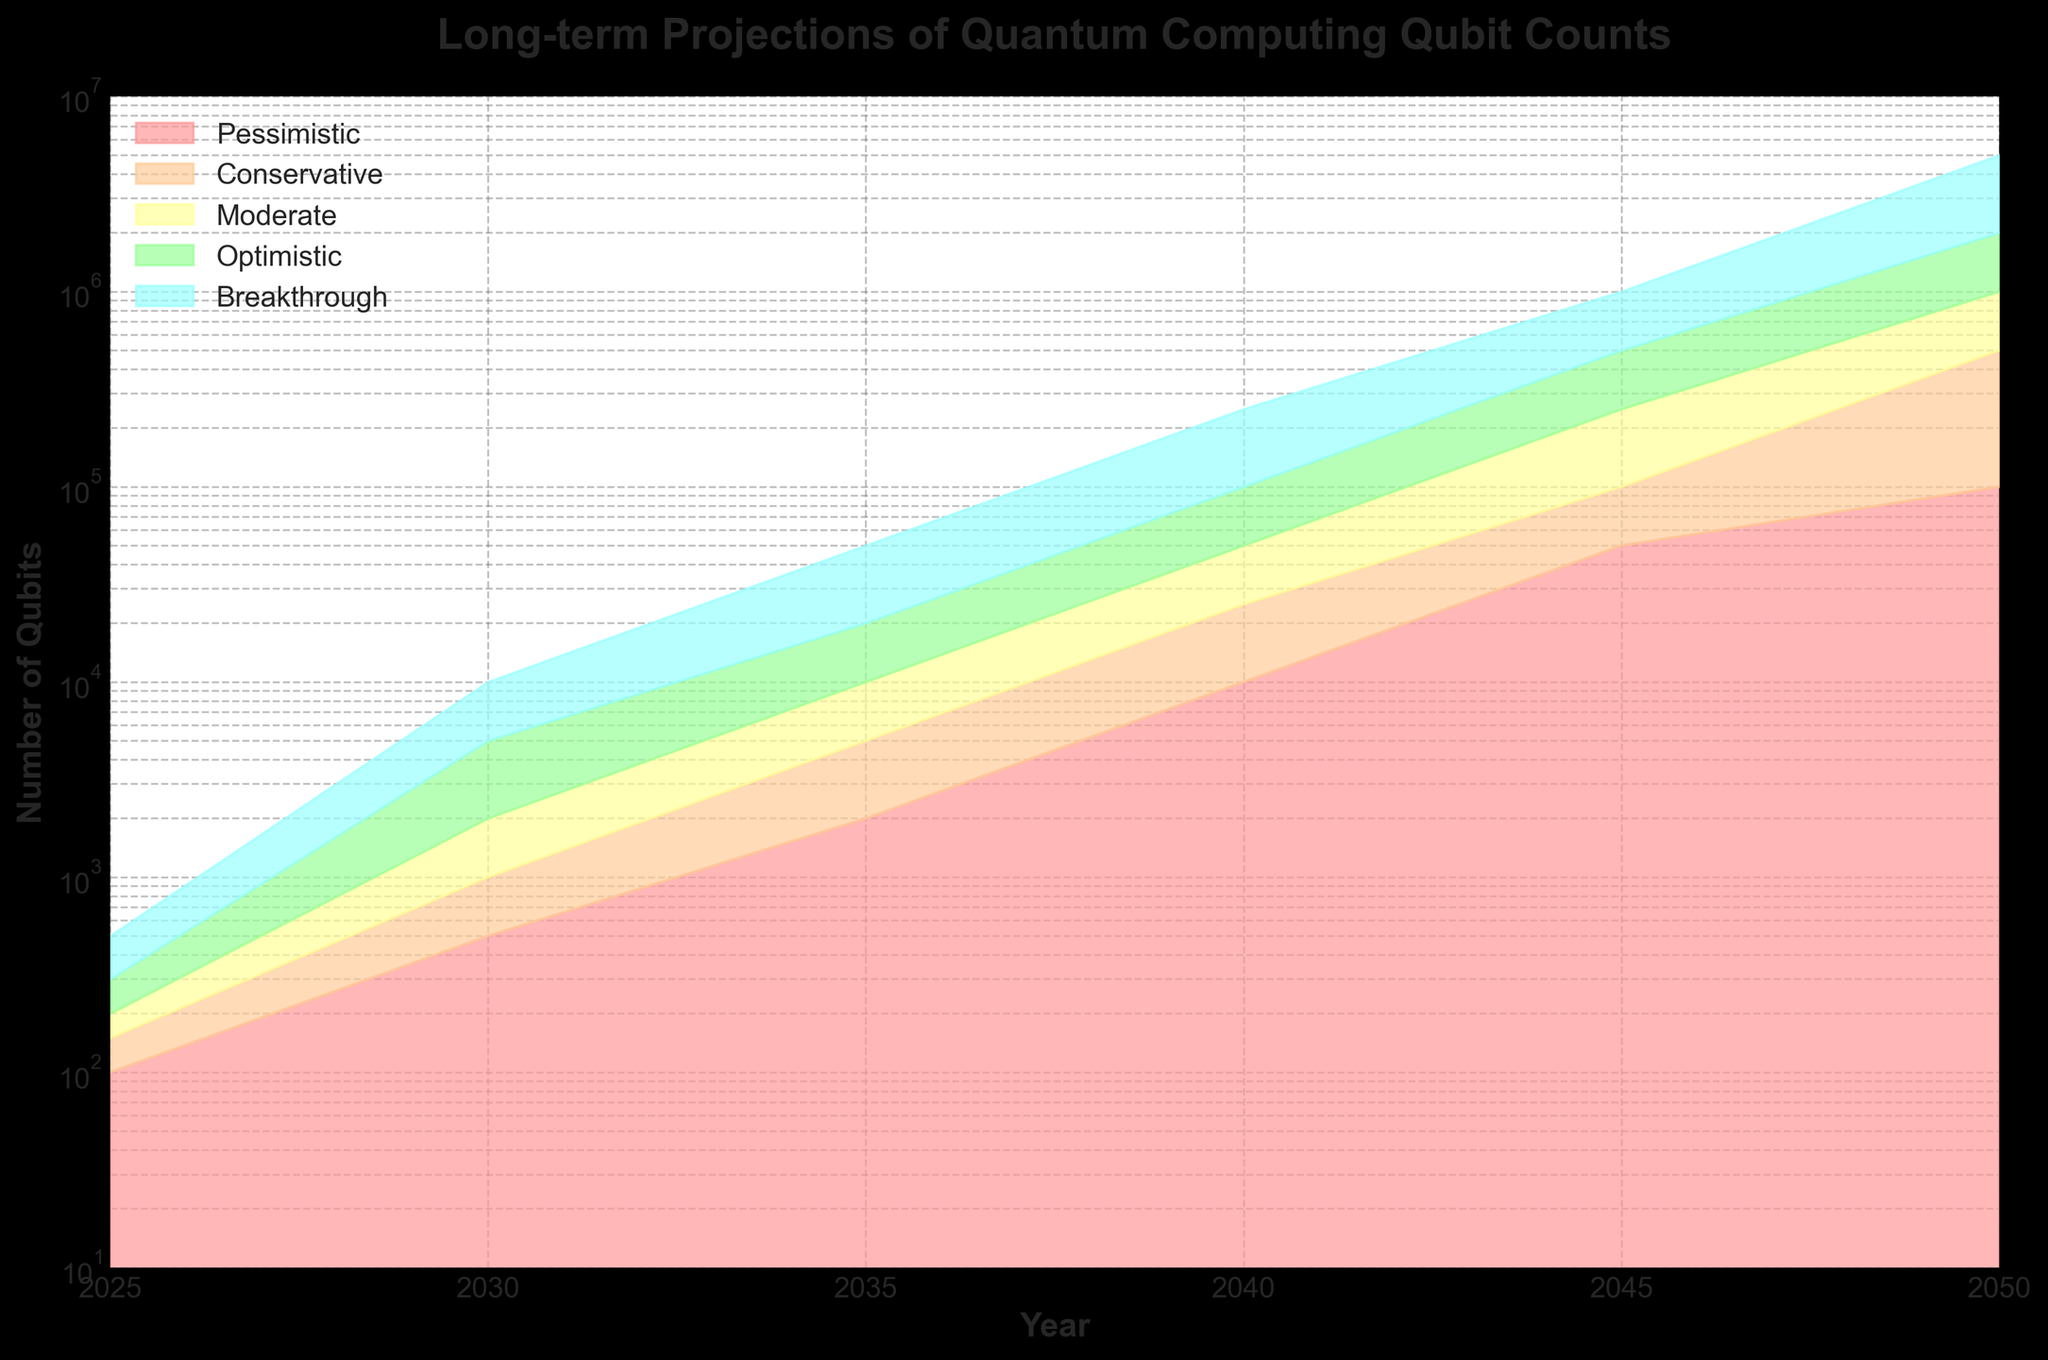What's the title of the figure? The title is prominently displayed at the top of the figure. It reads "Long-term Projections of Quantum Computing Qubit Counts".
Answer: Long-term Projections of Quantum Computing Qubit Counts What is the y-axis scale? The y-axis uses a logarithmic scale, which is indicated by the labels and consistent spacing of orders of magnitude (10, 100, 1000, etc.).
Answer: Logarithmic Which scenario shows the most conservative growth rate? By looking at the different colored bands, the scenario labeled "Pessimistic" depicts the slowest, most conservative growth rate across all years.
Answer: Pessimistic What is the number of qubits projected for the year 2035 under the breakthrough scenario? Locate the year 2035 on the x-axis and look at the highest (fifth) band for the breakthrough scenario, which shows 50,000.
Answer: 50,000 Between which years does the projected qubit count for the conservative scenario jump from approximately 1,000 to 100,000? Trace the conservative band from when it is near 1,000 to when it reaches 100,000. This occurs between the years 2030 and 2045.
Answer: 2030 and 2045 By how much is the number of qubits under the optimistic scenario expected to increase between 2025 and 2040? Locate the optimistic band for 2025 and 2040 and note the qubit counts at these points. For 2025, it is 300; for 2040, it is 100,000. The increase is 100,000 - 300 = 99,700.
Answer: 99,700 For the year 2050, which scenario projects the highest number of qubits, and what is that number? For the year 2050, identify the highest band which corresponds to the breakthrough scenario, projecting 5,000,000 qubits.
Answer: Breakthrough, 5,000,000 Are there any years where the moderate and optimistic projections are equal? Compare the moderate and optimistic bands year by year. They do not overlap exactly at any year, so there are no years where their projections are equal.
Answer: No How does the growth rate of the breakthrough scenario compare to the conservative scenario by the year 2045? Compare the heights of the breakthrough and conservative bands in 2045. The breakthrough scenario projects 1,000,000 qubits, whereas the conservative projects 100,000, showing the breakthrough scenario has a significantly steeper growth rate.
Answer: Breakthrough is significantly higher than conservative In which year do all scenarios predict at least 10,000 qubits? Check when the lowest band (pessimistic scenario) first reaches at least 10,000. This occurs by the year 2040.
Answer: 2040 